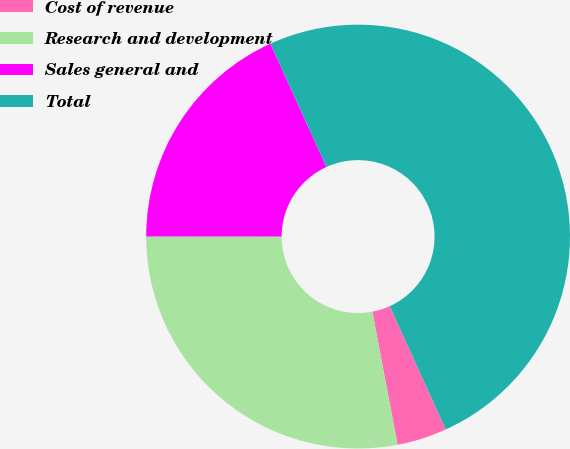Convert chart to OTSL. <chart><loc_0><loc_0><loc_500><loc_500><pie_chart><fcel>Cost of revenue<fcel>Research and development<fcel>Sales general and<fcel>Total<nl><fcel>3.81%<fcel>27.99%<fcel>18.2%<fcel>50.0%<nl></chart> 